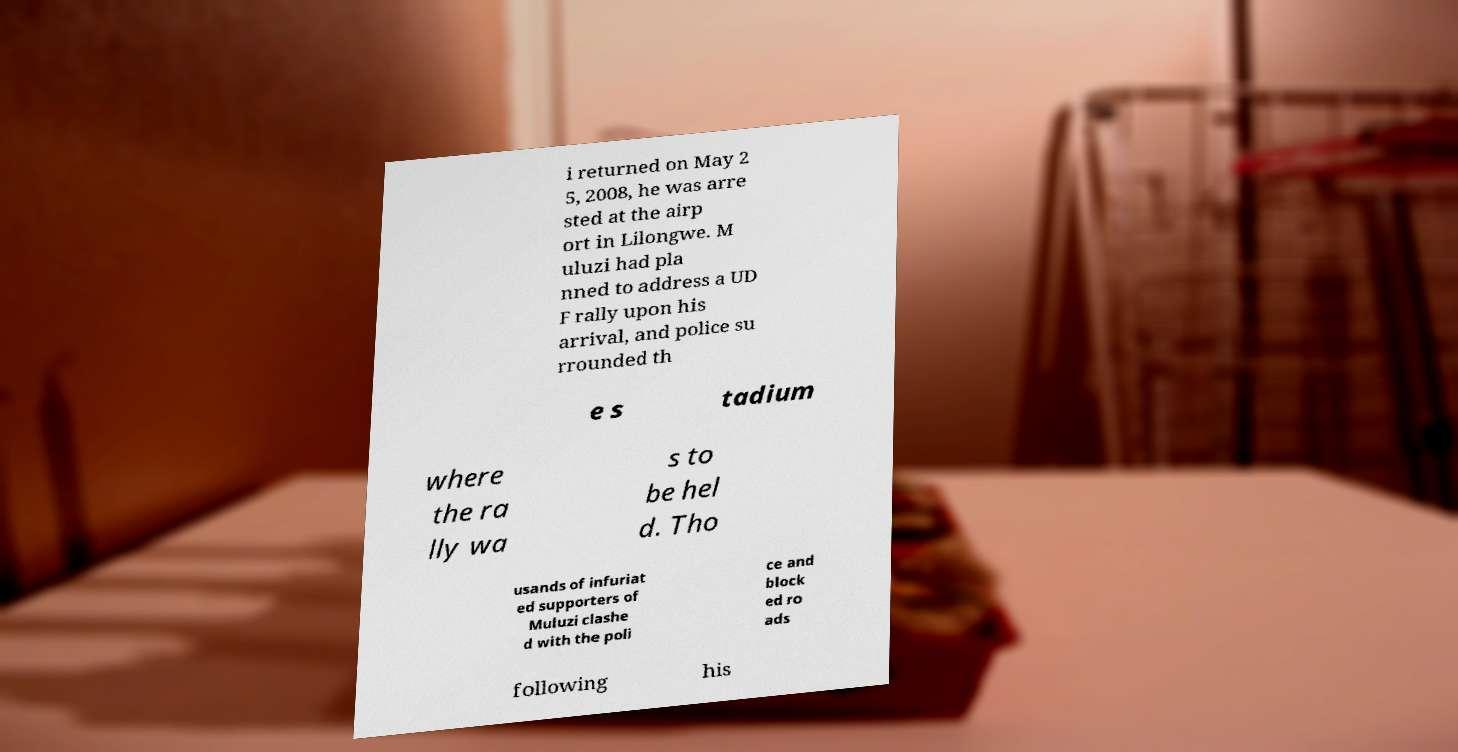Could you assist in decoding the text presented in this image and type it out clearly? i returned on May 2 5, 2008, he was arre sted at the airp ort in Lilongwe. M uluzi had pla nned to address a UD F rally upon his arrival, and police su rrounded th e s tadium where the ra lly wa s to be hel d. Tho usands of infuriat ed supporters of Muluzi clashe d with the poli ce and block ed ro ads following his 